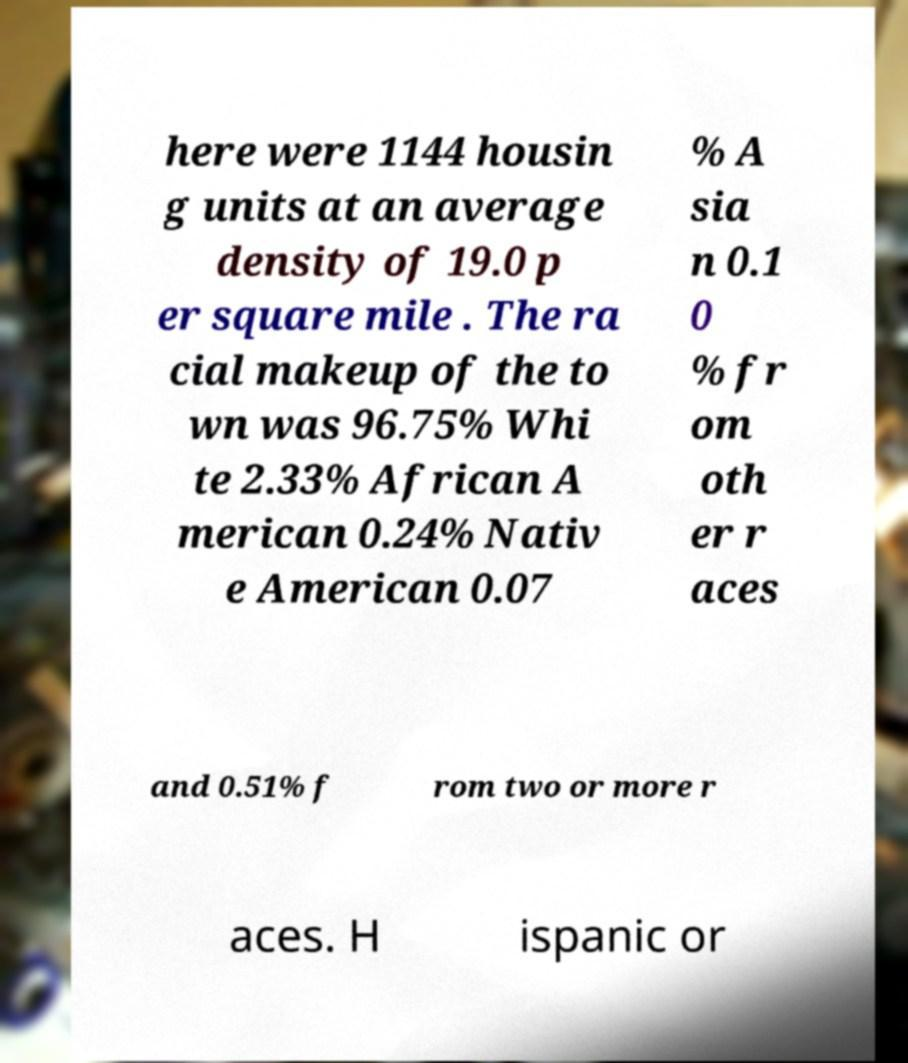Can you read and provide the text displayed in the image?This photo seems to have some interesting text. Can you extract and type it out for me? here were 1144 housin g units at an average density of 19.0 p er square mile . The ra cial makeup of the to wn was 96.75% Whi te 2.33% African A merican 0.24% Nativ e American 0.07 % A sia n 0.1 0 % fr om oth er r aces and 0.51% f rom two or more r aces. H ispanic or 